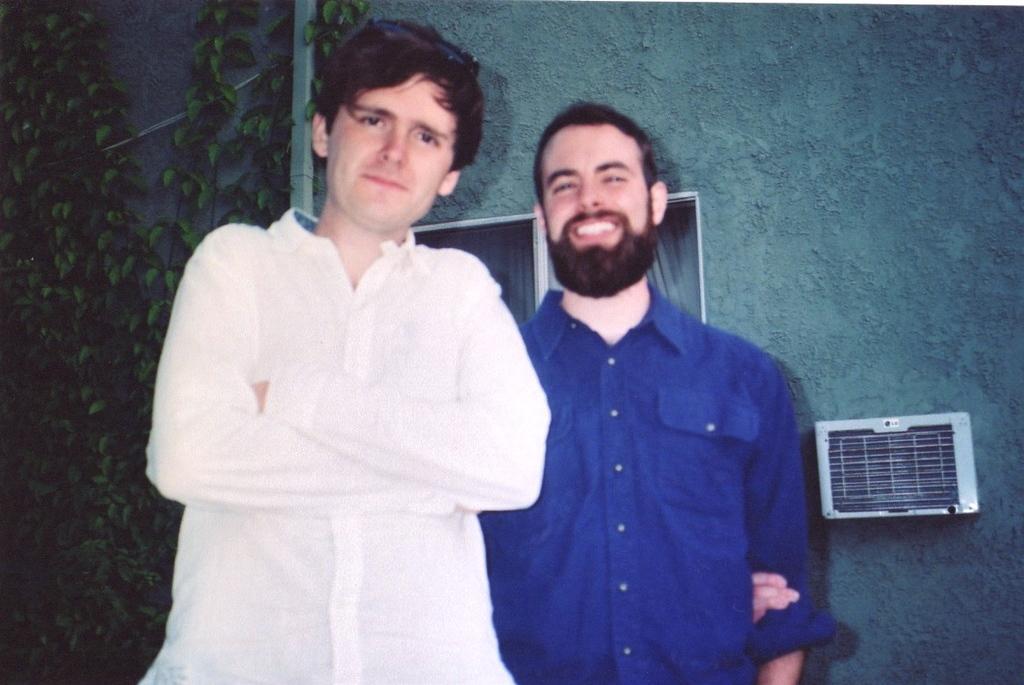In one or two sentences, can you explain what this image depicts? There are two people standing. In the back there is a wall. On the wall there are windows, creepers and a white color box. 